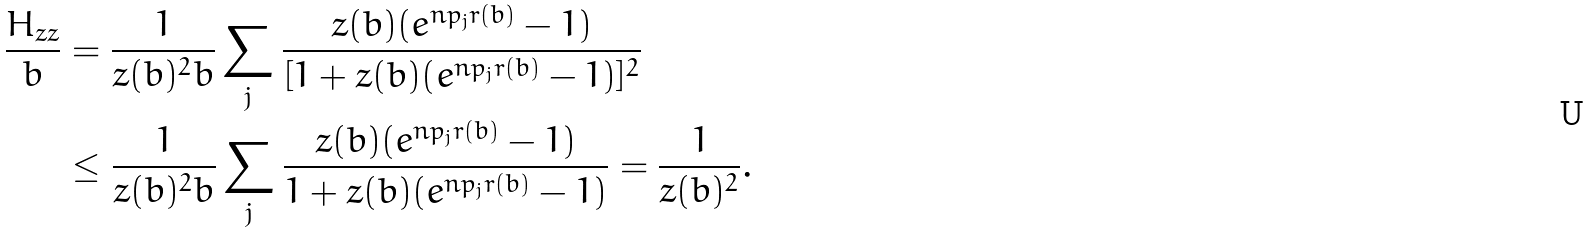Convert formula to latex. <formula><loc_0><loc_0><loc_500><loc_500>\frac { H _ { z z } } { b } & = \frac { 1 } { z ( b ) ^ { 2 } b } \sum _ { j } \frac { z ( b ) ( e ^ { n p _ { j } r ( b ) } - 1 ) } { [ 1 + z ( b ) ( e ^ { n p _ { j } r ( b ) } - 1 ) ] ^ { 2 } } \\ & \leq \frac { 1 } { z ( b ) ^ { 2 } b } \sum _ { j } \frac { z ( b ) ( e ^ { n p _ { j } r ( b ) } - 1 ) } { 1 + z ( b ) ( e ^ { n p _ { j } r ( b ) } - 1 ) } = \frac { 1 } { z ( b ) ^ { 2 } } .</formula> 